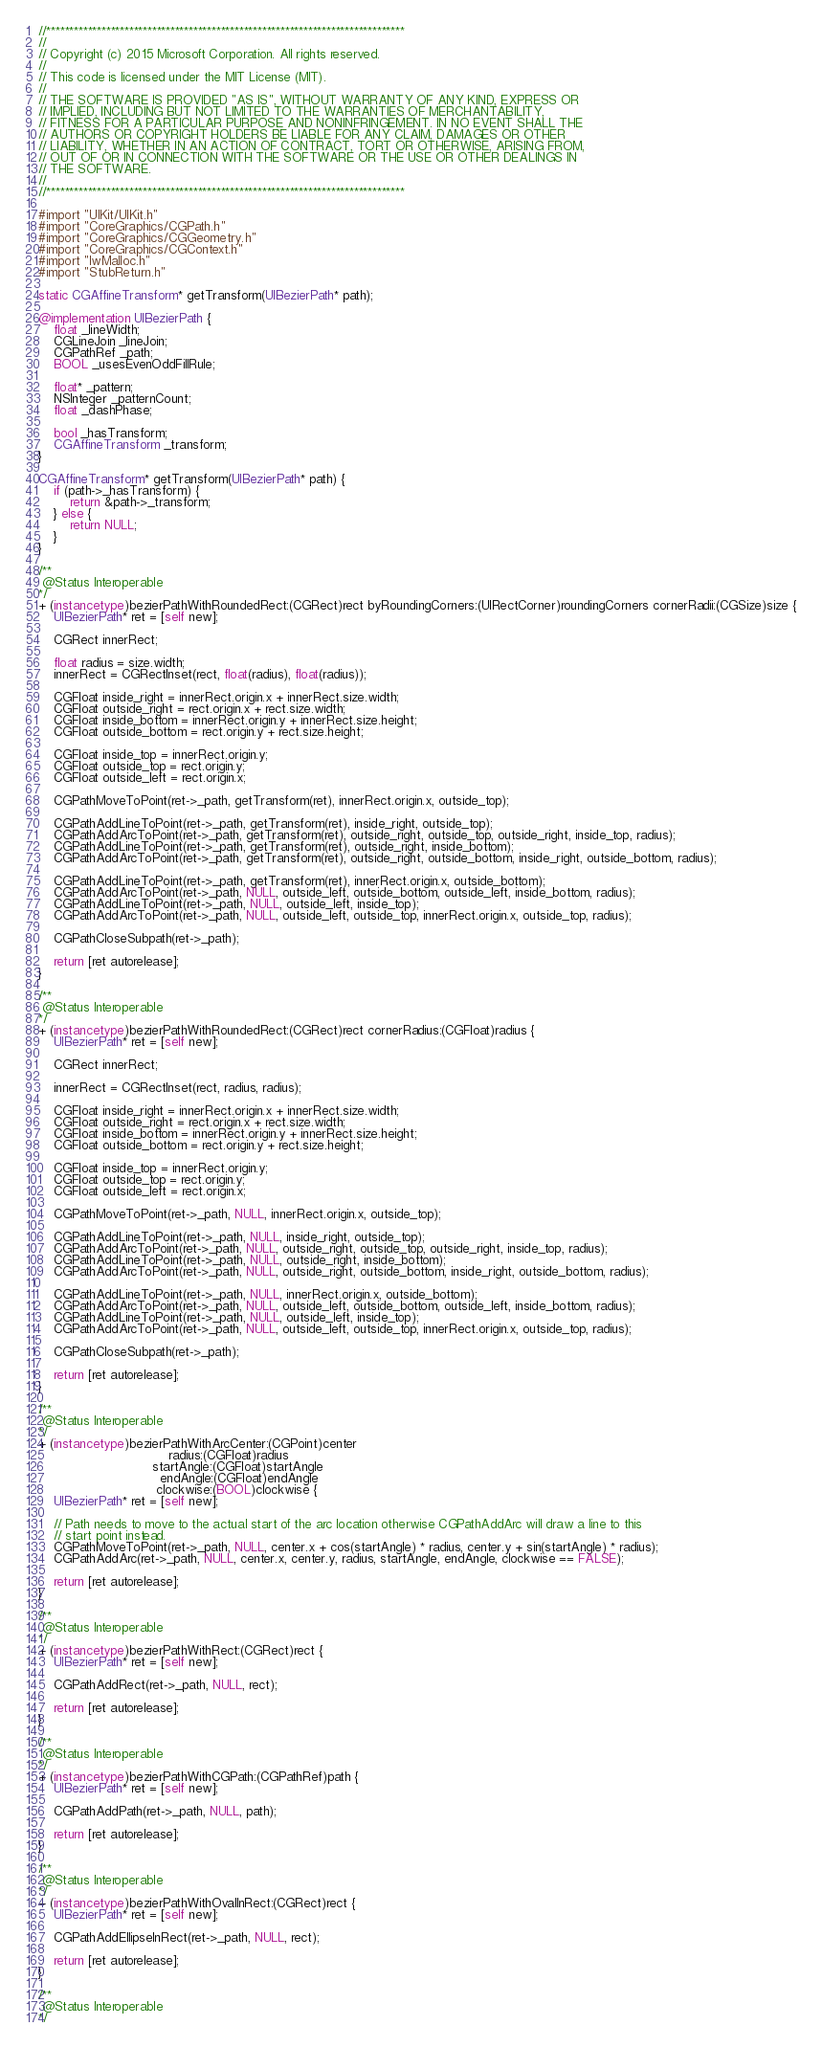<code> <loc_0><loc_0><loc_500><loc_500><_ObjectiveC_>//******************************************************************************
//
// Copyright (c) 2015 Microsoft Corporation. All rights reserved.
//
// This code is licensed under the MIT License (MIT).
//
// THE SOFTWARE IS PROVIDED "AS IS", WITHOUT WARRANTY OF ANY KIND, EXPRESS OR
// IMPLIED, INCLUDING BUT NOT LIMITED TO THE WARRANTIES OF MERCHANTABILITY,
// FITNESS FOR A PARTICULAR PURPOSE AND NONINFRINGEMENT. IN NO EVENT SHALL THE
// AUTHORS OR COPYRIGHT HOLDERS BE LIABLE FOR ANY CLAIM, DAMAGES OR OTHER
// LIABILITY, WHETHER IN AN ACTION OF CONTRACT, TORT OR OTHERWISE, ARISING FROM,
// OUT OF OR IN CONNECTION WITH THE SOFTWARE OR THE USE OR OTHER DEALINGS IN
// THE SOFTWARE.
//
//******************************************************************************

#import "UIKit/UIKit.h"
#import "CoreGraphics/CGPath.h"
#import "CoreGraphics/CGGeometry.h"
#import "CoreGraphics/CGContext.h"
#import "IwMalloc.h"
#import "StubReturn.h"

static CGAffineTransform* getTransform(UIBezierPath* path);

@implementation UIBezierPath {
    float _lineWidth;
    CGLineJoin _lineJoin;
    CGPathRef _path;
    BOOL _usesEvenOddFillRule;

    float* _pattern;
    NSInteger _patternCount;
    float _dashPhase;

    bool _hasTransform;
    CGAffineTransform _transform;
}

CGAffineTransform* getTransform(UIBezierPath* path) {
    if (path->_hasTransform) {
        return &path->_transform;
    } else {
        return NULL;
    }
}

/**
 @Status Interoperable
*/
+ (instancetype)bezierPathWithRoundedRect:(CGRect)rect byRoundingCorners:(UIRectCorner)roundingCorners cornerRadii:(CGSize)size {
    UIBezierPath* ret = [self new];

    CGRect innerRect;

    float radius = size.width;
    innerRect = CGRectInset(rect, float(radius), float(radius));

    CGFloat inside_right = innerRect.origin.x + innerRect.size.width;
    CGFloat outside_right = rect.origin.x + rect.size.width;
    CGFloat inside_bottom = innerRect.origin.y + innerRect.size.height;
    CGFloat outside_bottom = rect.origin.y + rect.size.height;

    CGFloat inside_top = innerRect.origin.y;
    CGFloat outside_top = rect.origin.y;
    CGFloat outside_left = rect.origin.x;

    CGPathMoveToPoint(ret->_path, getTransform(ret), innerRect.origin.x, outside_top);

    CGPathAddLineToPoint(ret->_path, getTransform(ret), inside_right, outside_top);
    CGPathAddArcToPoint(ret->_path, getTransform(ret), outside_right, outside_top, outside_right, inside_top, radius);
    CGPathAddLineToPoint(ret->_path, getTransform(ret), outside_right, inside_bottom);
    CGPathAddArcToPoint(ret->_path, getTransform(ret), outside_right, outside_bottom, inside_right, outside_bottom, radius);

    CGPathAddLineToPoint(ret->_path, getTransform(ret), innerRect.origin.x, outside_bottom);
    CGPathAddArcToPoint(ret->_path, NULL, outside_left, outside_bottom, outside_left, inside_bottom, radius);
    CGPathAddLineToPoint(ret->_path, NULL, outside_left, inside_top);
    CGPathAddArcToPoint(ret->_path, NULL, outside_left, outside_top, innerRect.origin.x, outside_top, radius);

    CGPathCloseSubpath(ret->_path);

    return [ret autorelease];
}

/**
 @Status Interoperable
*/
+ (instancetype)bezierPathWithRoundedRect:(CGRect)rect cornerRadius:(CGFloat)radius {
    UIBezierPath* ret = [self new];

    CGRect innerRect;

    innerRect = CGRectInset(rect, radius, radius);

    CGFloat inside_right = innerRect.origin.x + innerRect.size.width;
    CGFloat outside_right = rect.origin.x + rect.size.width;
    CGFloat inside_bottom = innerRect.origin.y + innerRect.size.height;
    CGFloat outside_bottom = rect.origin.y + rect.size.height;

    CGFloat inside_top = innerRect.origin.y;
    CGFloat outside_top = rect.origin.y;
    CGFloat outside_left = rect.origin.x;

    CGPathMoveToPoint(ret->_path, NULL, innerRect.origin.x, outside_top);

    CGPathAddLineToPoint(ret->_path, NULL, inside_right, outside_top);
    CGPathAddArcToPoint(ret->_path, NULL, outside_right, outside_top, outside_right, inside_top, radius);
    CGPathAddLineToPoint(ret->_path, NULL, outside_right, inside_bottom);
    CGPathAddArcToPoint(ret->_path, NULL, outside_right, outside_bottom, inside_right, outside_bottom, radius);

    CGPathAddLineToPoint(ret->_path, NULL, innerRect.origin.x, outside_bottom);
    CGPathAddArcToPoint(ret->_path, NULL, outside_left, outside_bottom, outside_left, inside_bottom, radius);
    CGPathAddLineToPoint(ret->_path, NULL, outside_left, inside_top);
    CGPathAddArcToPoint(ret->_path, NULL, outside_left, outside_top, innerRect.origin.x, outside_top, radius);

    CGPathCloseSubpath(ret->_path);

    return [ret autorelease];
}

/**
 @Status Interoperable
*/
+ (instancetype)bezierPathWithArcCenter:(CGPoint)center
                                 radius:(CGFloat)radius
                             startAngle:(CGFloat)startAngle
                               endAngle:(CGFloat)endAngle
                              clockwise:(BOOL)clockwise {
    UIBezierPath* ret = [self new];

    // Path needs to move to the actual start of the arc location otherwise CGPathAddArc will draw a line to this
    // start point instead.
    CGPathMoveToPoint(ret->_path, NULL, center.x + cos(startAngle) * radius, center.y + sin(startAngle) * radius);
    CGPathAddArc(ret->_path, NULL, center.x, center.y, radius, startAngle, endAngle, clockwise == FALSE);

    return [ret autorelease];
}

/**
 @Status Interoperable
*/
+ (instancetype)bezierPathWithRect:(CGRect)rect {
    UIBezierPath* ret = [self new];

    CGPathAddRect(ret->_path, NULL, rect);

    return [ret autorelease];
}

/**
 @Status Interoperable
*/
+ (instancetype)bezierPathWithCGPath:(CGPathRef)path {
    UIBezierPath* ret = [self new];

    CGPathAddPath(ret->_path, NULL, path);

    return [ret autorelease];
}

/**
 @Status Interoperable
*/
+ (instancetype)bezierPathWithOvalInRect:(CGRect)rect {
    UIBezierPath* ret = [self new];

    CGPathAddEllipseInRect(ret->_path, NULL, rect);

    return [ret autorelease];
}

/**
 @Status Interoperable
*/</code> 